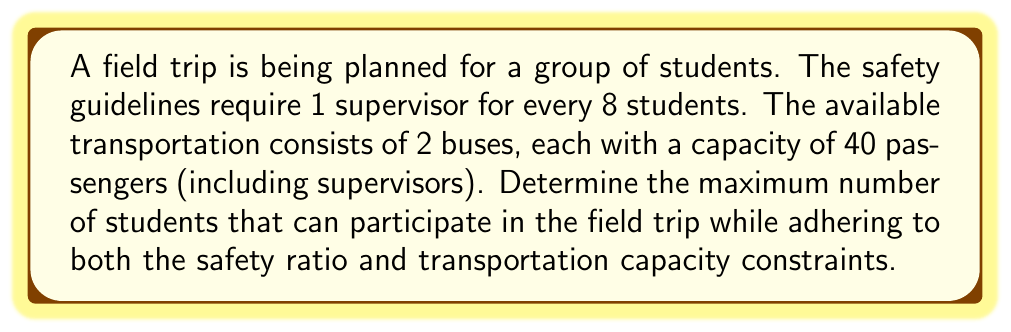Show me your answer to this math problem. Let's approach this step-by-step:

1) Let $x$ be the number of students and $y$ be the number of supervisors.

2) From the safety ratio, we know that:
   $$y = \frac{x}{8}$$

3) The total number of participants (students + supervisors) must not exceed the bus capacity:
   $$x + y \leq 80$$

4) Substituting the expression for $y$:
   $$x + \frac{x}{8} \leq 80$$

5) Simplifying:
   $$\frac{8x}{8} + \frac{x}{8} = \frac{9x}{8} \leq 80$$

6) Multiplying both sides by 8:
   $$9x \leq 640$$

7) Solving for $x$:
   $$x \leq \frac{640}{9} = 71.11...$$

8) Since we can't have a fractional number of students, we round down to the nearest whole number:
   $$x = 71$$

9) Verify the number of supervisors:
   $$y = \frac{71}{8} = 8.875$$
   Rounding up (as we need at least this many supervisors): $y = 9$

10) Final check:
    Students (71) + Supervisors (9) = 80, which matches the bus capacity.

Therefore, the maximum number of students that can participate is 71.
Answer: 71 students 